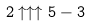<formula> <loc_0><loc_0><loc_500><loc_500>2 \uparrow \uparrow \uparrow 5 - 3</formula> 